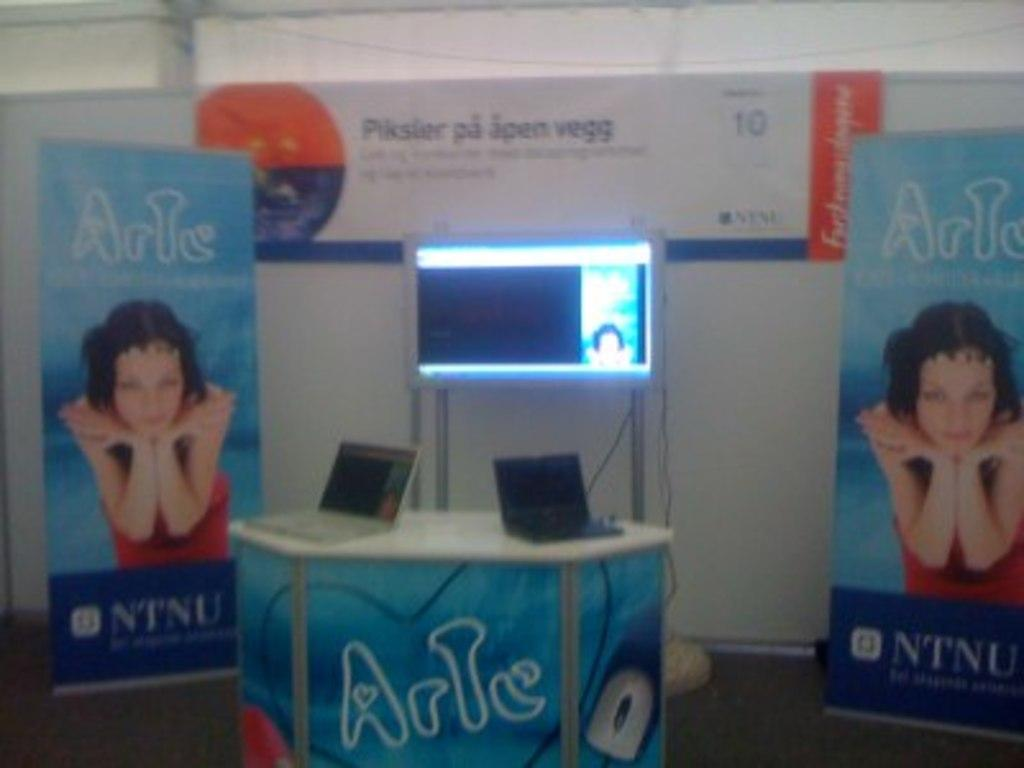What can be seen in the foreground of the image? There are two banners, a screen, a wall, and two laptops on a table in the foreground of the image. How many banners are visible in the image? There are two banners in the foreground of the image. What is the purpose of the screen in the image? The purpose of the screen is not specified in the provided facts, but it is visible in the foreground of the image. Where are the laptops located in the image? The laptops are on a table in the foreground of the image. What type of belief is represented by the ants in the image? There are no ants present in the image, so it is not possible to determine what belief they might represent. 